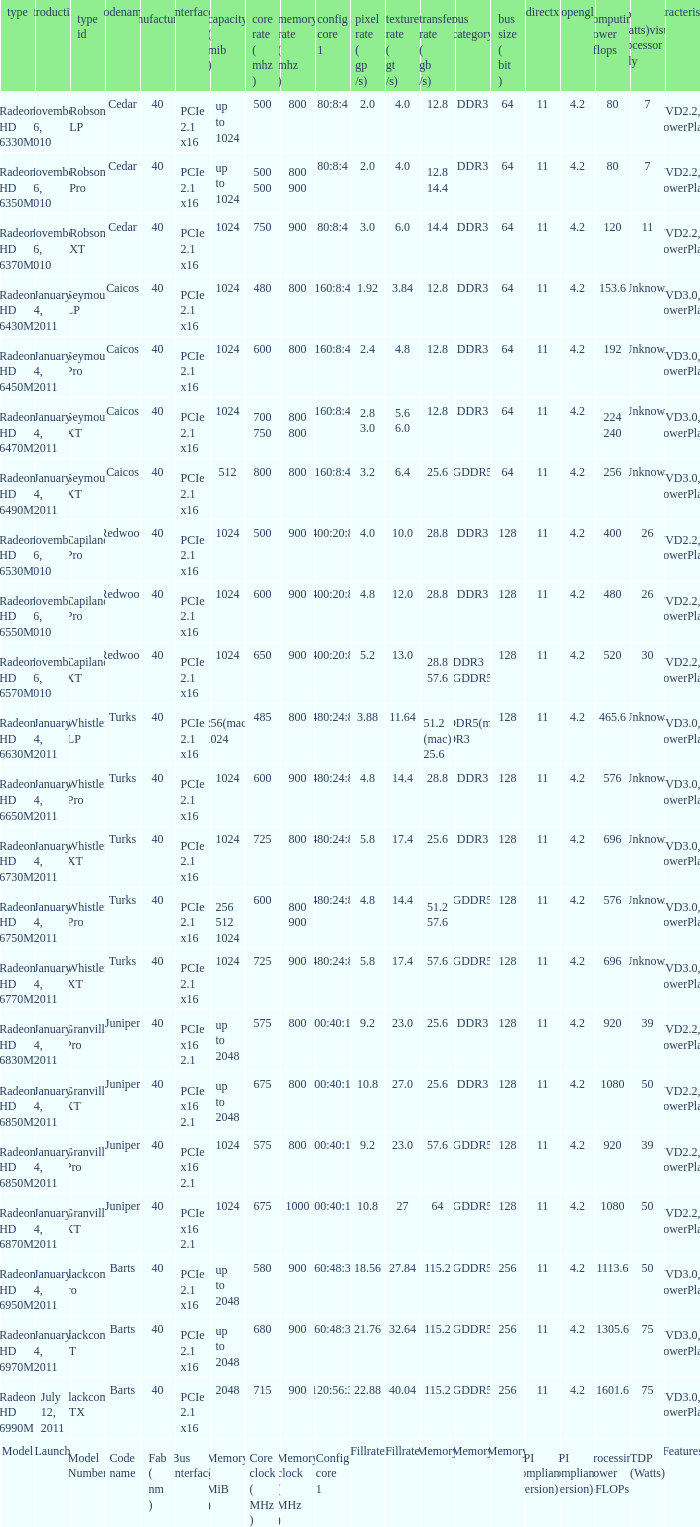Identify all the code names used for the model radeon hd 6650m. Turks. 